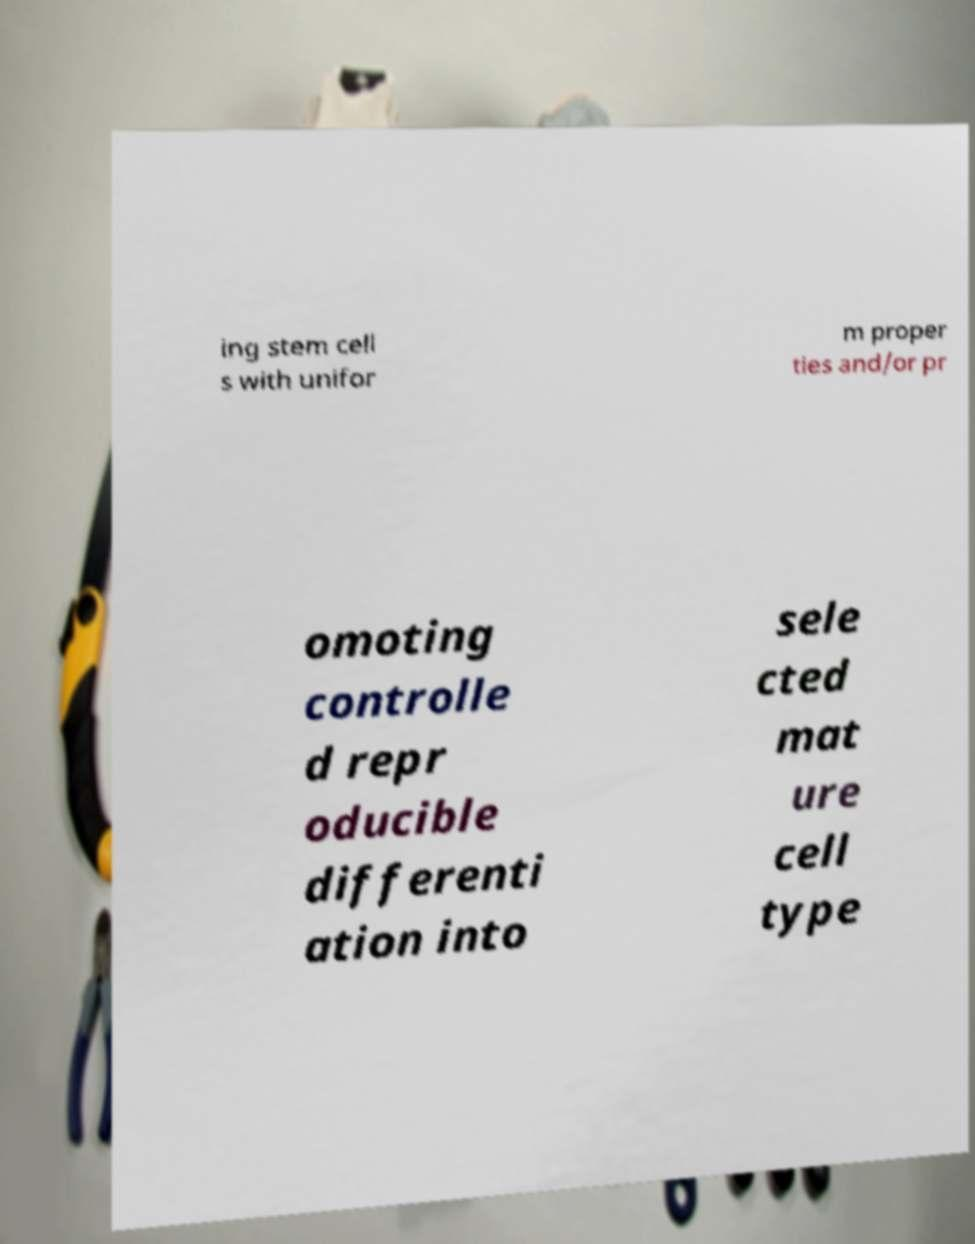There's text embedded in this image that I need extracted. Can you transcribe it verbatim? ing stem cell s with unifor m proper ties and/or pr omoting controlle d repr oducible differenti ation into sele cted mat ure cell type 